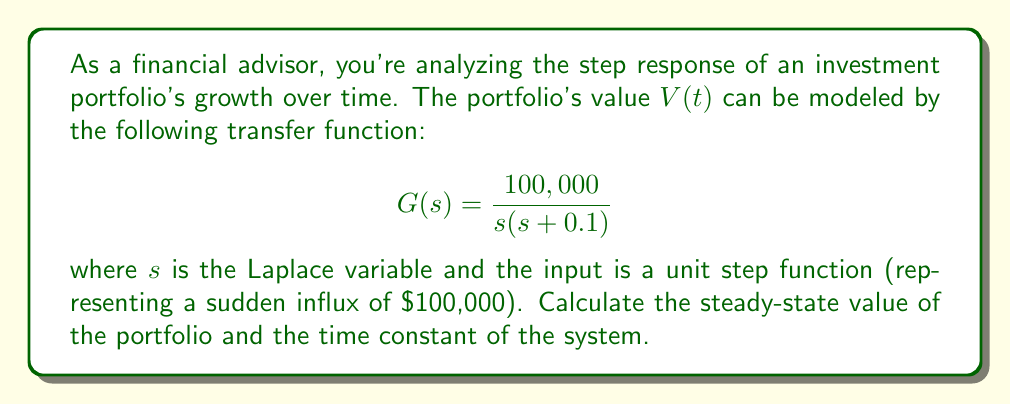Show me your answer to this math problem. To analyze the step response of this investment portfolio, we'll follow these steps:

1. Steady-state value calculation:
   The steady-state value can be found using the Final Value Theorem:
   $$\lim_{t \to \infty} V(t) = \lim_{s \to 0} sG(s)U(s)$$
   where $U(s) = \frac{1}{s}$ for a unit step input.

   $$\lim_{t \to \infty} V(t) = \lim_{s \to 0} s \cdot \frac{100,000}{s(s + 0.1)} \cdot \frac{1}{s}$$
   $$= \lim_{s \to 0} \frac{100,000}{s + 0.1} = 1,000,000$$

2. Time constant calculation:
   The transfer function can be rewritten as:
   $$G(s) = \frac{100,000}{s(s + 0.1)} = \frac{1,000,000}{s} - \frac{1,000,000}{s + 0.1}$$

   The inverse Laplace transform gives us the time-domain response:
   $$V(t) = 1,000,000 - 1,000,000e^{-0.1t}$$

   The time constant $\tau$ is the reciprocal of the exponent coefficient:
   $$\tau = \frac{1}{0.1} = 10 \text{ years}$$

This means the portfolio will reach approximately 63.2% of its final value after 10 years.
Answer: Steady-state value: $1,000,000
Time constant: 10 years 